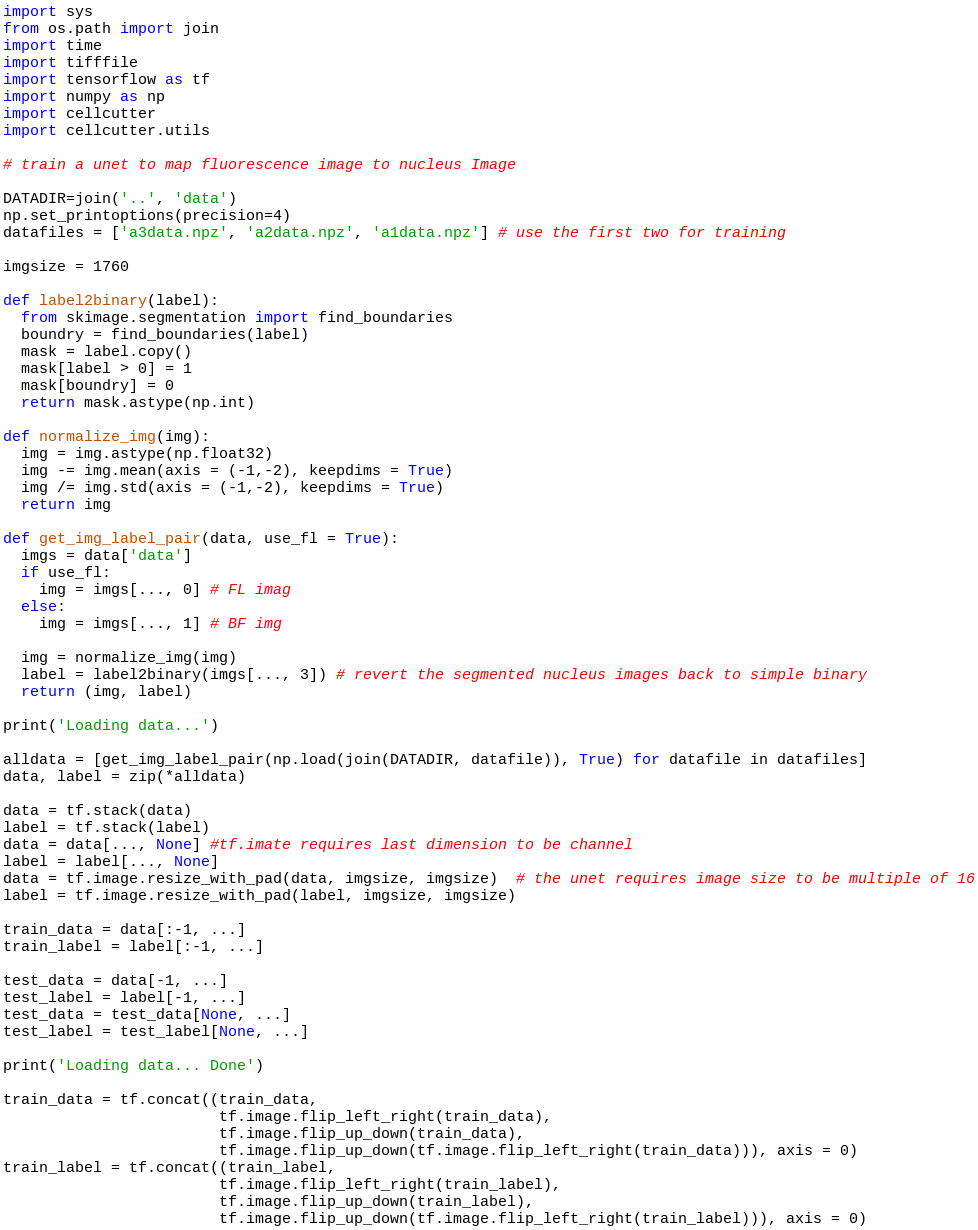<code> <loc_0><loc_0><loc_500><loc_500><_Python_>import sys
from os.path import join
import time
import tifffile
import tensorflow as tf
import numpy as np
import cellcutter
import cellcutter.utils

# train a unet to map fluorescence image to nucleus Image

DATADIR=join('..', 'data')
np.set_printoptions(precision=4)
datafiles = ['a3data.npz', 'a2data.npz', 'a1data.npz'] # use the first two for training

imgsize = 1760

def label2binary(label):
  from skimage.segmentation import find_boundaries
  boundry = find_boundaries(label)
  mask = label.copy()
  mask[label > 0] = 1
  mask[boundry] = 0
  return mask.astype(np.int)

def normalize_img(img):
  img = img.astype(np.float32)
  img -= img.mean(axis = (-1,-2), keepdims = True)
  img /= img.std(axis = (-1,-2), keepdims = True)
  return img

def get_img_label_pair(data, use_fl = True):
  imgs = data['data']
  if use_fl:
    img = imgs[..., 0] # FL imag
  else:
    img = imgs[..., 1] # BF img

  img = normalize_img(img)
  label = label2binary(imgs[..., 3]) # revert the segmented nucleus images back to simple binary
  return (img, label)

print('Loading data...')

alldata = [get_img_label_pair(np.load(join(DATADIR, datafile)), True) for datafile in datafiles]
data, label = zip(*alldata)

data = tf.stack(data)
label = tf.stack(label)
data = data[..., None] #tf.imate requires last dimension to be channel
label = label[..., None]
data = tf.image.resize_with_pad(data, imgsize, imgsize)  # the unet requires image size to be multiple of 16
label = tf.image.resize_with_pad(label, imgsize, imgsize)

train_data = data[:-1, ...]
train_label = label[:-1, ...]

test_data = data[-1, ...]
test_label = label[-1, ...]
test_data = test_data[None, ...]
test_label = test_label[None, ...]

print('Loading data... Done')

train_data = tf.concat((train_data,
                        tf.image.flip_left_right(train_data),
                        tf.image.flip_up_down(train_data),
                        tf.image.flip_up_down(tf.image.flip_left_right(train_data))), axis = 0)
train_label = tf.concat((train_label,
                        tf.image.flip_left_right(train_label),
                        tf.image.flip_up_down(train_label),
                        tf.image.flip_up_down(tf.image.flip_left_right(train_label))), axis = 0)
</code> 